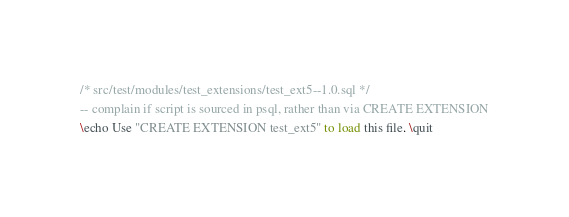<code> <loc_0><loc_0><loc_500><loc_500><_SQL_>/* src/test/modules/test_extensions/test_ext5--1.0.sql */
-- complain if script is sourced in psql, rather than via CREATE EXTENSION
\echo Use "CREATE EXTENSION test_ext5" to load this file. \quit
</code> 